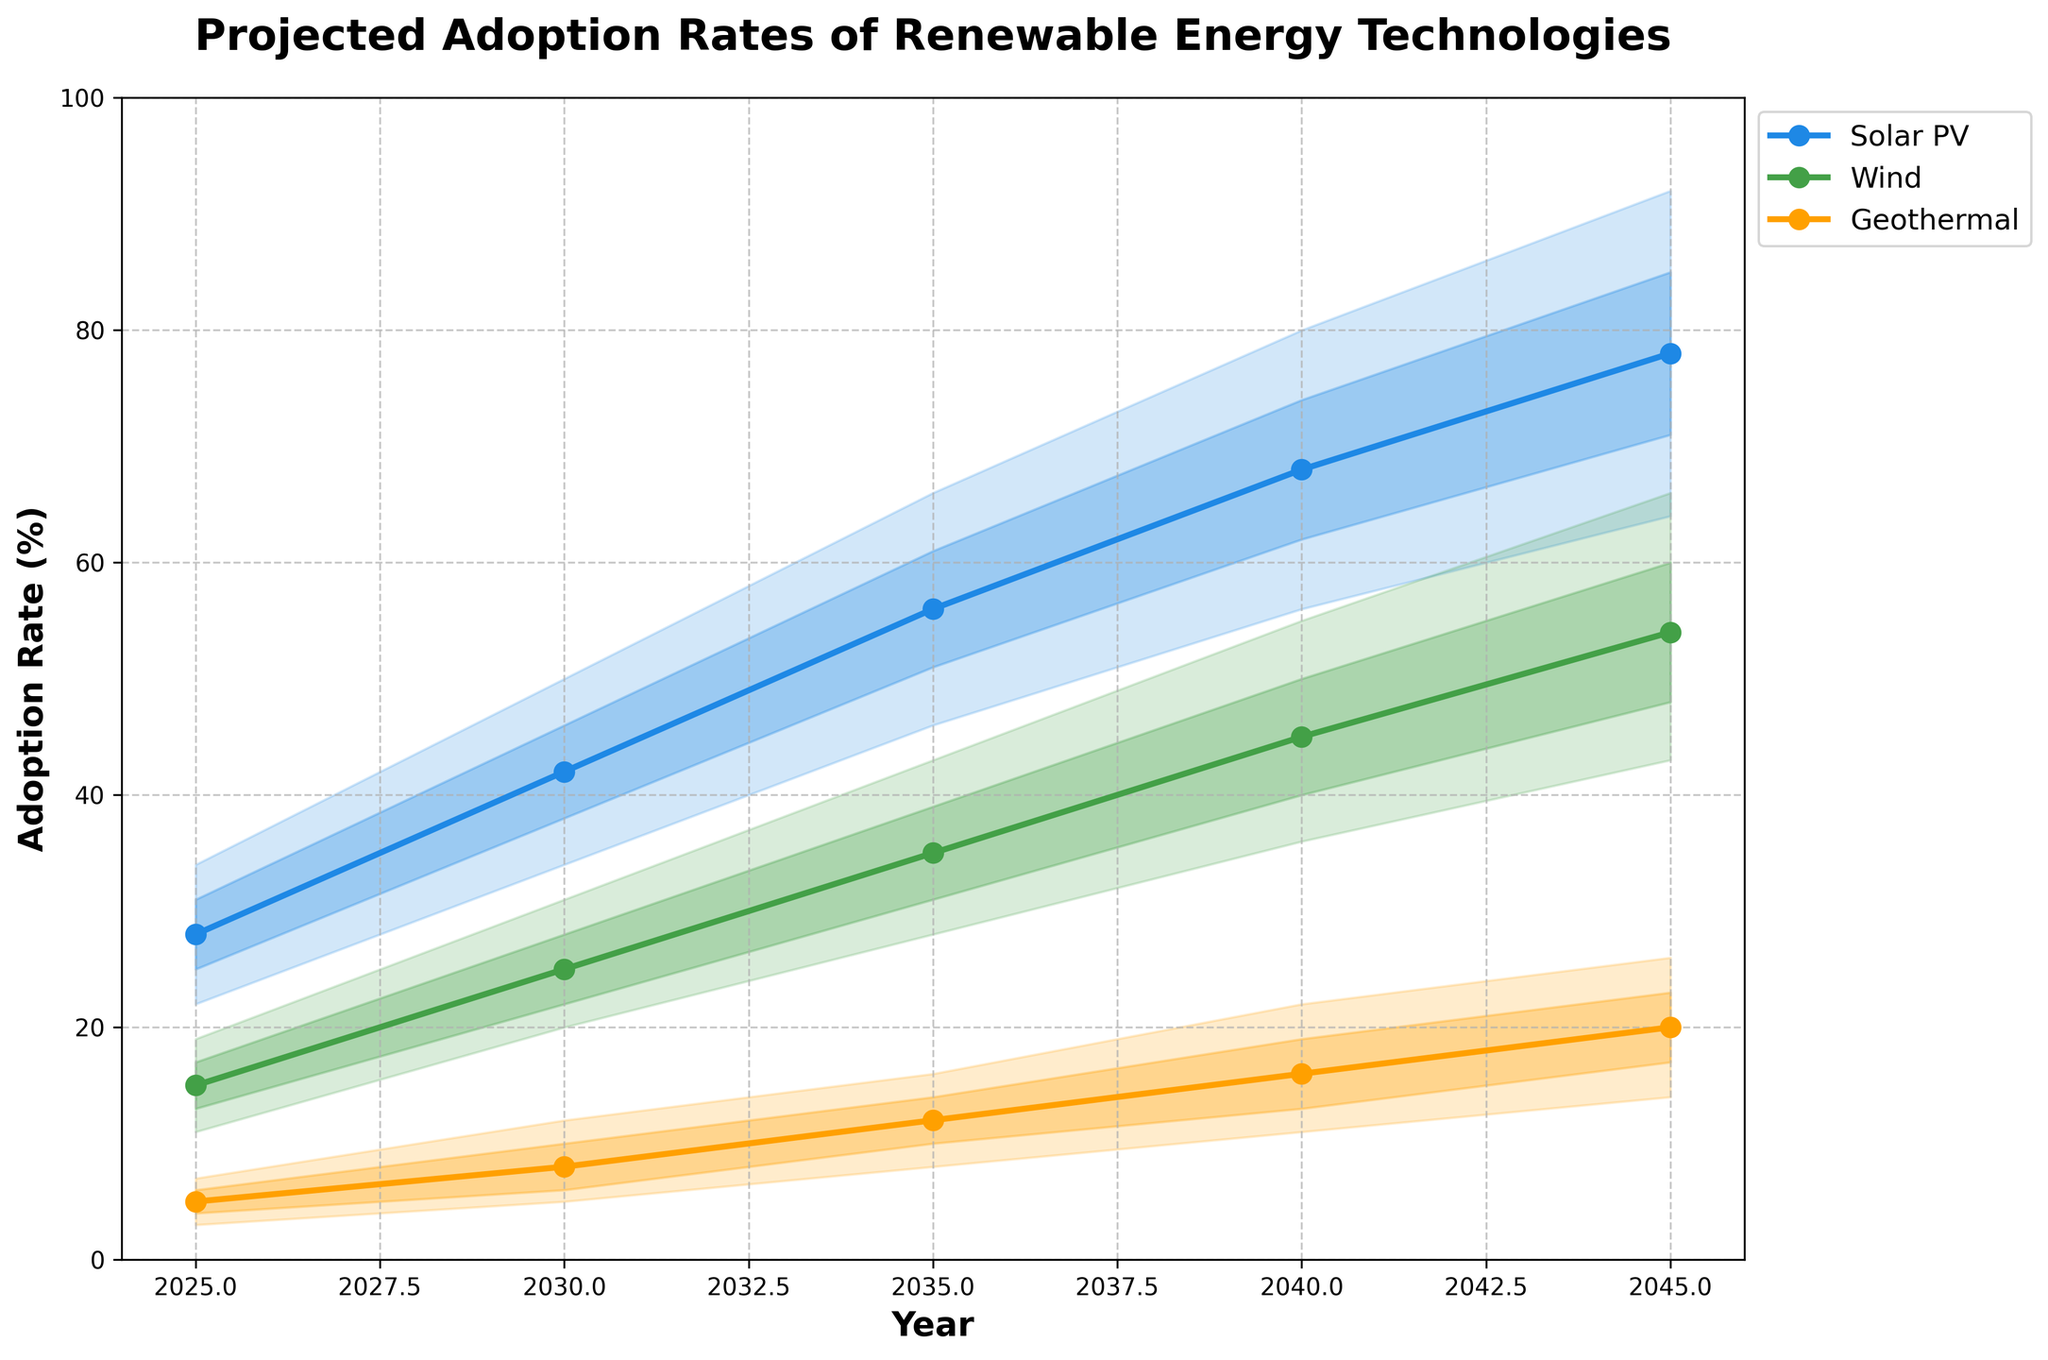What's the title of the figure? The title of a figure is typically located at the top, and it provides a summary of what the figure is about. In this case, the title is clearly stated at the top of the rendered image.
Answer: Projected Adoption Rates of Renewable Energy Technologies What is the projected adoption rate for Wind in 2045 as per the central projection? To find this, look for the Wind technology line for the year 2045, and then locate the central projection value which is marked by a line or a data point.
Answer: 54% Which technology has the highest central projection in 2030? Compare the central projection values for all technologies in 2030. Identify which technology has the highest value among Solar PV, Wind, and Geothermal.
Answer: Solar PV How does the adoption rate range (from Lower 10% to Upper 90%) for Solar PV in 2040 compare to Wind in the same year? For Solar PV in 2040, the lower 10% is 56% and the upper 90% is 80%, resulting in a range of 24 percentage points. For Wind, the lower 10% is 36% and the upper 90% is 55%, resulting in a range of 19 percentage points. Compare these two ranges.
Answer: Solar PV has a larger range Between which years does Solar PV show the largest increase in central projection? Calculate the increase in central projection for Solar PV between consecutive years and identify the pair of years with the largest increase.
Answer: 2025 to 2030 What's the difference between the lower 25% and upper 75% projections for Geothermal in 2035? Subtract the lower 25% value from the upper 75% value for Geothermal in 2035. The lower 25% is 10% and the upper 75% is 14%.
Answer: 4% Which technology shows the smallest variability (narrowest 10% to 90% range) in projections across all years? Examine the ranges of the three technologies between the lower 10% and upper 90% bounds for all the years, and find which shows the smallest variability overall.
Answer: Geothermal How do the upper bounds (90th percentile) of Solar PV and Wind compare in 2035? Look at the upper 90% values for Solar PV and Wind in 2035. For Solar PV, the value is 66%, and for Wind, it is 43%. Compare these values.
Answer: Solar PV has a higher upper bound In which year is the central projection of Geothermal expected to reach 20%? Look for the year in the Geothermal technology line where the central projection value is 20%. According to the data, this level is projected by 2045.
Answer: 2045 